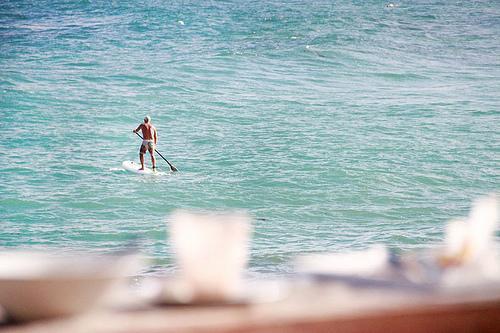How many guys are in the photo?
Give a very brief answer. 1. 